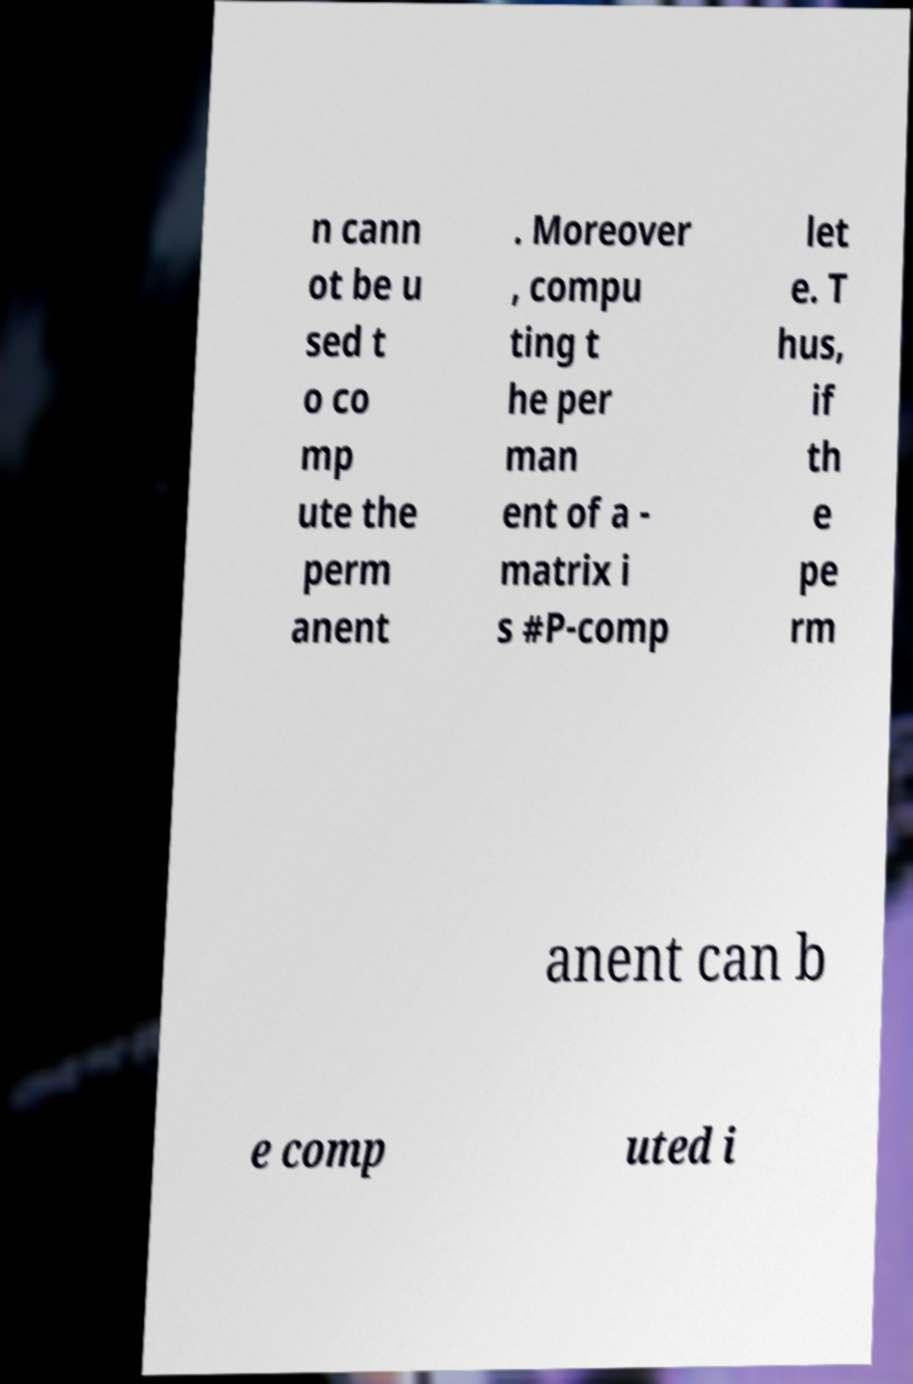Please identify and transcribe the text found in this image. n cann ot be u sed t o co mp ute the perm anent . Moreover , compu ting t he per man ent of a - matrix i s #P-comp let e. T hus, if th e pe rm anent can b e comp uted i 